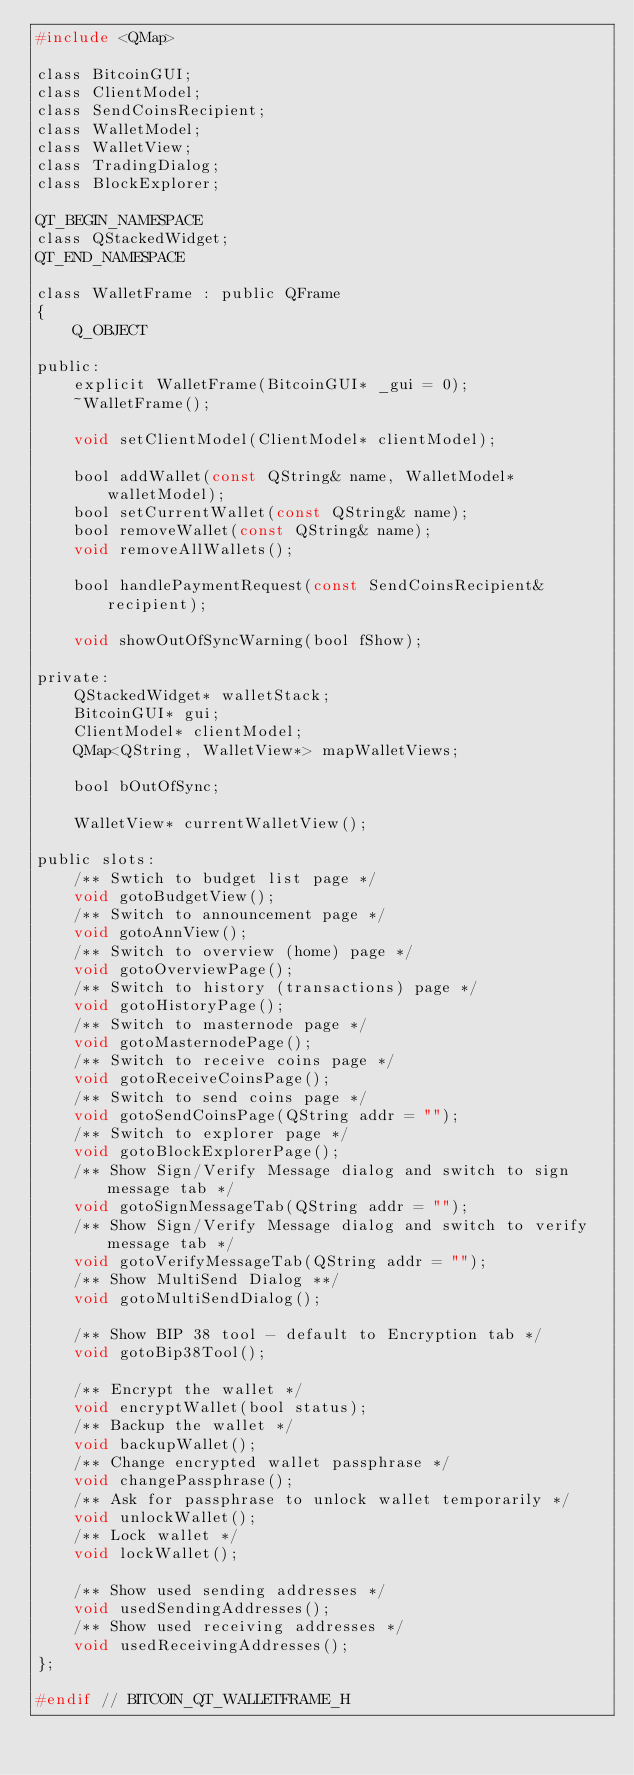Convert code to text. <code><loc_0><loc_0><loc_500><loc_500><_C_>#include <QMap>

class BitcoinGUI;
class ClientModel;
class SendCoinsRecipient;
class WalletModel;
class WalletView;
class TradingDialog;
class BlockExplorer;

QT_BEGIN_NAMESPACE
class QStackedWidget;
QT_END_NAMESPACE

class WalletFrame : public QFrame
{
    Q_OBJECT

public:
    explicit WalletFrame(BitcoinGUI* _gui = 0);
    ~WalletFrame();

    void setClientModel(ClientModel* clientModel);

    bool addWallet(const QString& name, WalletModel* walletModel);
    bool setCurrentWallet(const QString& name);
    bool removeWallet(const QString& name);
    void removeAllWallets();

    bool handlePaymentRequest(const SendCoinsRecipient& recipient);

    void showOutOfSyncWarning(bool fShow);

private:
    QStackedWidget* walletStack;
    BitcoinGUI* gui;
    ClientModel* clientModel;
    QMap<QString, WalletView*> mapWalletViews;

    bool bOutOfSync;

    WalletView* currentWalletView();

public slots:
    /** Swtich to budget list page */
    void gotoBudgetView();
    /** Switch to announcement page */
    void gotoAnnView();
    /** Switch to overview (home) page */
    void gotoOverviewPage();
    /** Switch to history (transactions) page */
    void gotoHistoryPage();
    /** Switch to masternode page */
    void gotoMasternodePage();
    /** Switch to receive coins page */
    void gotoReceiveCoinsPage();
    /** Switch to send coins page */
    void gotoSendCoinsPage(QString addr = "");
    /** Switch to explorer page */
    void gotoBlockExplorerPage();
    /** Show Sign/Verify Message dialog and switch to sign message tab */
    void gotoSignMessageTab(QString addr = "");
    /** Show Sign/Verify Message dialog and switch to verify message tab */
    void gotoVerifyMessageTab(QString addr = "");
    /** Show MultiSend Dialog **/
    void gotoMultiSendDialog();

    /** Show BIP 38 tool - default to Encryption tab */
    void gotoBip38Tool();

    /** Encrypt the wallet */
    void encryptWallet(bool status);
    /** Backup the wallet */
    void backupWallet();
    /** Change encrypted wallet passphrase */
    void changePassphrase();
    /** Ask for passphrase to unlock wallet temporarily */
    void unlockWallet();
    /** Lock wallet */
    void lockWallet();

    /** Show used sending addresses */
    void usedSendingAddresses();
    /** Show used receiving addresses */
    void usedReceivingAddresses();
};

#endif // BITCOIN_QT_WALLETFRAME_H
</code> 